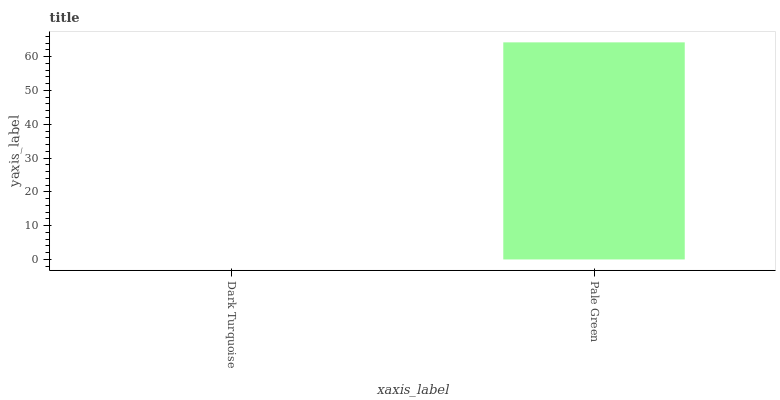Is Dark Turquoise the minimum?
Answer yes or no. Yes. Is Pale Green the maximum?
Answer yes or no. Yes. Is Pale Green the minimum?
Answer yes or no. No. Is Pale Green greater than Dark Turquoise?
Answer yes or no. Yes. Is Dark Turquoise less than Pale Green?
Answer yes or no. Yes. Is Dark Turquoise greater than Pale Green?
Answer yes or no. No. Is Pale Green less than Dark Turquoise?
Answer yes or no. No. Is Pale Green the high median?
Answer yes or no. Yes. Is Dark Turquoise the low median?
Answer yes or no. Yes. Is Dark Turquoise the high median?
Answer yes or no. No. Is Pale Green the low median?
Answer yes or no. No. 